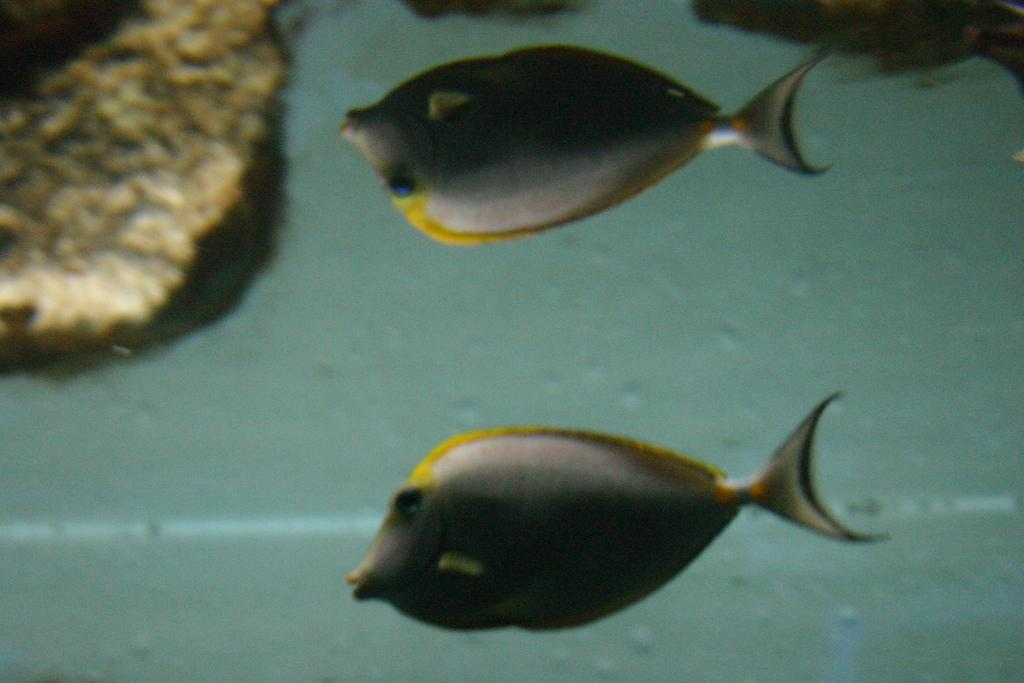What type of animals can be seen in the image? There are fishes in the image. Where are the fishes located? The fishes are in the water. What type of feather can be seen on the goose in the image? There is no goose or feather present in the image; it features fishes in the water. 